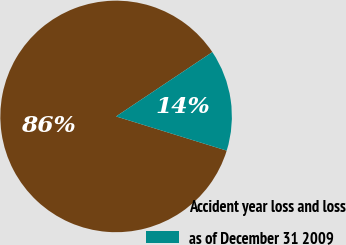<chart> <loc_0><loc_0><loc_500><loc_500><pie_chart><fcel>Accident year loss and loss<fcel>as of December 31 2009<nl><fcel>85.85%<fcel>14.15%<nl></chart> 